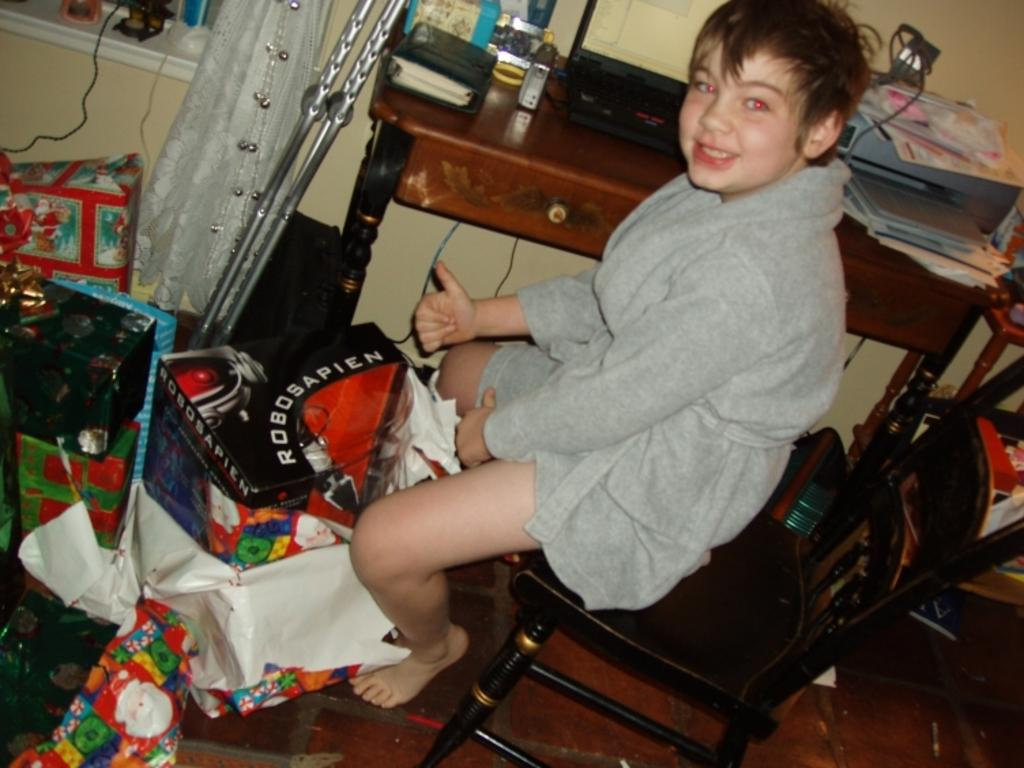What is the main subject in the middle of the image? There is a boy sitting on a chair in the middle of the image. What is located beside the boy? There is a table beside the boy. What can be seen on the left side of the image? There are unspecified objects on the left side of the image. What type of drum is being played by the boy in the image? There is no drum present in the image; the boy is simply sitting on a chair. What color is the curtain behind the boy in the image? There is no curtain visible in the image; the background is not described in the provided facts. 